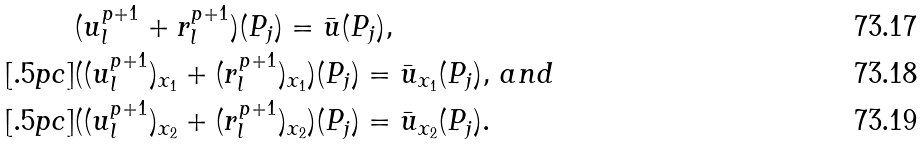<formula> <loc_0><loc_0><loc_500><loc_500>& ( u _ { l } ^ { p + 1 } + r _ { l } ^ { p + 1 } ) ( P _ { j } ) = \bar { u } ( P _ { j } ) , \\ [ . 5 p c ] & ( ( u _ { l } ^ { p + 1 } ) _ { x _ { 1 } } + ( r _ { l } ^ { p + 1 } ) _ { x _ { 1 } } ) ( P _ { j } ) = \bar { u } _ { x _ { 1 } } ( P _ { j } ) , \, a n d \\ [ . 5 p c ] & ( ( u _ { l } ^ { p + 1 } ) _ { x _ { 2 } } + ( r _ { l } ^ { p + 1 } ) _ { x _ { 2 } } ) ( P _ { j } ) = \bar { u } _ { x _ { 2 } } ( P _ { j } ) .</formula> 